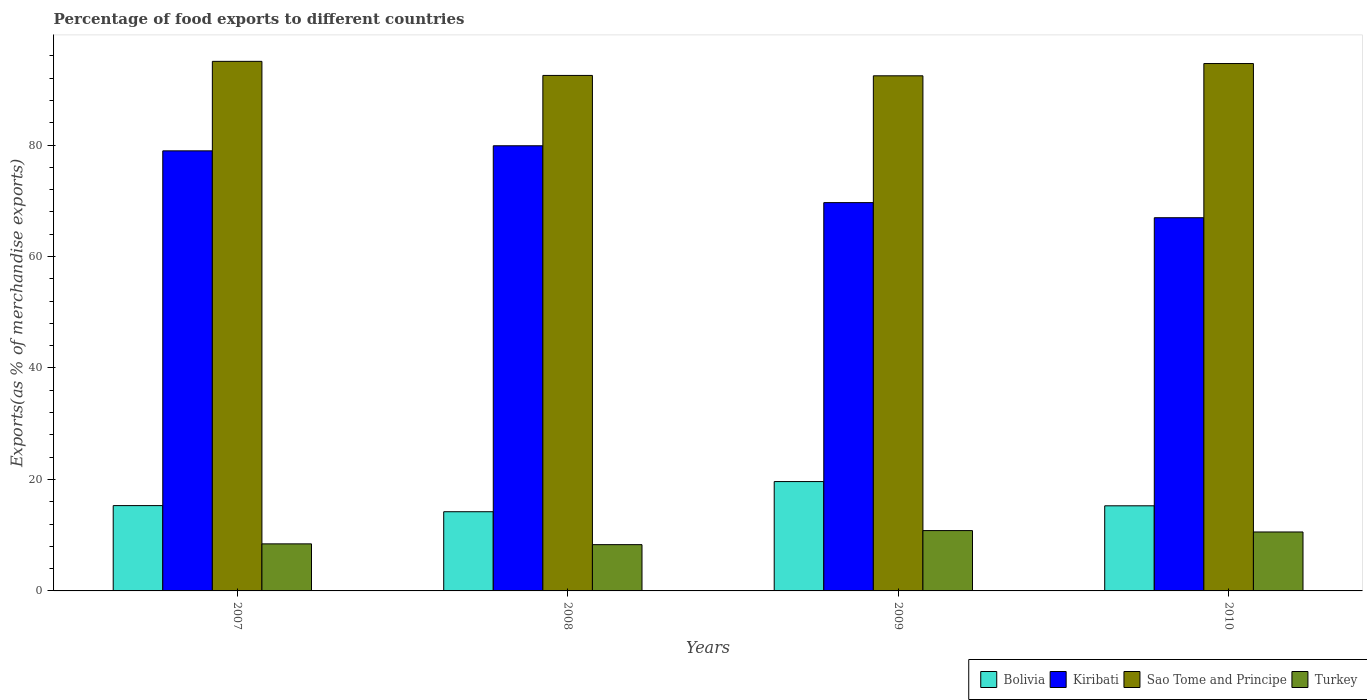How many different coloured bars are there?
Provide a succinct answer. 4. Are the number of bars per tick equal to the number of legend labels?
Your answer should be compact. Yes. How many bars are there on the 4th tick from the left?
Your response must be concise. 4. What is the percentage of exports to different countries in Bolivia in 2009?
Provide a short and direct response. 19.62. Across all years, what is the maximum percentage of exports to different countries in Turkey?
Your answer should be compact. 10.83. Across all years, what is the minimum percentage of exports to different countries in Sao Tome and Principe?
Provide a short and direct response. 92.42. What is the total percentage of exports to different countries in Turkey in the graph?
Provide a succinct answer. 38.15. What is the difference between the percentage of exports to different countries in Bolivia in 2009 and that in 2010?
Provide a short and direct response. 4.35. What is the difference between the percentage of exports to different countries in Sao Tome and Principe in 2010 and the percentage of exports to different countries in Kiribati in 2009?
Your answer should be compact. 24.95. What is the average percentage of exports to different countries in Turkey per year?
Ensure brevity in your answer.  9.54. In the year 2007, what is the difference between the percentage of exports to different countries in Kiribati and percentage of exports to different countries in Bolivia?
Your response must be concise. 63.64. In how many years, is the percentage of exports to different countries in Bolivia greater than 72 %?
Your answer should be very brief. 0. What is the ratio of the percentage of exports to different countries in Sao Tome and Principe in 2007 to that in 2009?
Give a very brief answer. 1.03. Is the percentage of exports to different countries in Sao Tome and Principe in 2007 less than that in 2010?
Ensure brevity in your answer.  No. What is the difference between the highest and the second highest percentage of exports to different countries in Bolivia?
Provide a short and direct response. 4.31. What is the difference between the highest and the lowest percentage of exports to different countries in Sao Tome and Principe?
Give a very brief answer. 2.59. What does the 2nd bar from the left in 2009 represents?
Offer a very short reply. Kiribati. What does the 4th bar from the right in 2010 represents?
Keep it short and to the point. Bolivia. What is the difference between two consecutive major ticks on the Y-axis?
Ensure brevity in your answer.  20. Are the values on the major ticks of Y-axis written in scientific E-notation?
Your response must be concise. No. Does the graph contain grids?
Give a very brief answer. No. Where does the legend appear in the graph?
Your answer should be compact. Bottom right. How many legend labels are there?
Offer a very short reply. 4. How are the legend labels stacked?
Your answer should be compact. Horizontal. What is the title of the graph?
Keep it short and to the point. Percentage of food exports to different countries. What is the label or title of the X-axis?
Provide a short and direct response. Years. What is the label or title of the Y-axis?
Provide a short and direct response. Exports(as % of merchandise exports). What is the Exports(as % of merchandise exports) in Bolivia in 2007?
Make the answer very short. 15.31. What is the Exports(as % of merchandise exports) of Kiribati in 2007?
Keep it short and to the point. 78.95. What is the Exports(as % of merchandise exports) in Sao Tome and Principe in 2007?
Make the answer very short. 95.01. What is the Exports(as % of merchandise exports) in Turkey in 2007?
Give a very brief answer. 8.44. What is the Exports(as % of merchandise exports) of Bolivia in 2008?
Your answer should be compact. 14.21. What is the Exports(as % of merchandise exports) in Kiribati in 2008?
Ensure brevity in your answer.  79.86. What is the Exports(as % of merchandise exports) of Sao Tome and Principe in 2008?
Keep it short and to the point. 92.48. What is the Exports(as % of merchandise exports) in Turkey in 2008?
Offer a terse response. 8.3. What is the Exports(as % of merchandise exports) in Bolivia in 2009?
Give a very brief answer. 19.62. What is the Exports(as % of merchandise exports) of Kiribati in 2009?
Make the answer very short. 69.66. What is the Exports(as % of merchandise exports) in Sao Tome and Principe in 2009?
Ensure brevity in your answer.  92.42. What is the Exports(as % of merchandise exports) in Turkey in 2009?
Offer a terse response. 10.83. What is the Exports(as % of merchandise exports) in Bolivia in 2010?
Keep it short and to the point. 15.27. What is the Exports(as % of merchandise exports) in Kiribati in 2010?
Your response must be concise. 66.95. What is the Exports(as % of merchandise exports) in Sao Tome and Principe in 2010?
Offer a terse response. 94.62. What is the Exports(as % of merchandise exports) in Turkey in 2010?
Give a very brief answer. 10.58. Across all years, what is the maximum Exports(as % of merchandise exports) of Bolivia?
Offer a terse response. 19.62. Across all years, what is the maximum Exports(as % of merchandise exports) of Kiribati?
Your response must be concise. 79.86. Across all years, what is the maximum Exports(as % of merchandise exports) in Sao Tome and Principe?
Provide a short and direct response. 95.01. Across all years, what is the maximum Exports(as % of merchandise exports) in Turkey?
Provide a short and direct response. 10.83. Across all years, what is the minimum Exports(as % of merchandise exports) of Bolivia?
Offer a very short reply. 14.21. Across all years, what is the minimum Exports(as % of merchandise exports) of Kiribati?
Provide a succinct answer. 66.95. Across all years, what is the minimum Exports(as % of merchandise exports) of Sao Tome and Principe?
Ensure brevity in your answer.  92.42. Across all years, what is the minimum Exports(as % of merchandise exports) of Turkey?
Offer a very short reply. 8.3. What is the total Exports(as % of merchandise exports) in Bolivia in the graph?
Offer a terse response. 64.41. What is the total Exports(as % of merchandise exports) in Kiribati in the graph?
Your answer should be very brief. 295.43. What is the total Exports(as % of merchandise exports) in Sao Tome and Principe in the graph?
Ensure brevity in your answer.  374.53. What is the total Exports(as % of merchandise exports) in Turkey in the graph?
Provide a short and direct response. 38.15. What is the difference between the Exports(as % of merchandise exports) of Bolivia in 2007 and that in 2008?
Your response must be concise. 1.1. What is the difference between the Exports(as % of merchandise exports) of Kiribati in 2007 and that in 2008?
Make the answer very short. -0.91. What is the difference between the Exports(as % of merchandise exports) in Sao Tome and Principe in 2007 and that in 2008?
Your answer should be compact. 2.52. What is the difference between the Exports(as % of merchandise exports) in Turkey in 2007 and that in 2008?
Offer a terse response. 0.14. What is the difference between the Exports(as % of merchandise exports) of Bolivia in 2007 and that in 2009?
Keep it short and to the point. -4.31. What is the difference between the Exports(as % of merchandise exports) of Kiribati in 2007 and that in 2009?
Your answer should be compact. 9.29. What is the difference between the Exports(as % of merchandise exports) of Sao Tome and Principe in 2007 and that in 2009?
Ensure brevity in your answer.  2.59. What is the difference between the Exports(as % of merchandise exports) of Turkey in 2007 and that in 2009?
Make the answer very short. -2.38. What is the difference between the Exports(as % of merchandise exports) of Bolivia in 2007 and that in 2010?
Ensure brevity in your answer.  0.04. What is the difference between the Exports(as % of merchandise exports) of Kiribati in 2007 and that in 2010?
Provide a succinct answer. 12. What is the difference between the Exports(as % of merchandise exports) of Sao Tome and Principe in 2007 and that in 2010?
Offer a very short reply. 0.39. What is the difference between the Exports(as % of merchandise exports) in Turkey in 2007 and that in 2010?
Provide a succinct answer. -2.13. What is the difference between the Exports(as % of merchandise exports) in Bolivia in 2008 and that in 2009?
Your answer should be very brief. -5.41. What is the difference between the Exports(as % of merchandise exports) in Kiribati in 2008 and that in 2009?
Your answer should be compact. 10.2. What is the difference between the Exports(as % of merchandise exports) in Sao Tome and Principe in 2008 and that in 2009?
Your answer should be compact. 0.07. What is the difference between the Exports(as % of merchandise exports) of Turkey in 2008 and that in 2009?
Provide a short and direct response. -2.52. What is the difference between the Exports(as % of merchandise exports) of Bolivia in 2008 and that in 2010?
Give a very brief answer. -1.06. What is the difference between the Exports(as % of merchandise exports) of Kiribati in 2008 and that in 2010?
Your response must be concise. 12.91. What is the difference between the Exports(as % of merchandise exports) of Sao Tome and Principe in 2008 and that in 2010?
Your response must be concise. -2.13. What is the difference between the Exports(as % of merchandise exports) of Turkey in 2008 and that in 2010?
Your answer should be very brief. -2.27. What is the difference between the Exports(as % of merchandise exports) in Bolivia in 2009 and that in 2010?
Provide a succinct answer. 4.35. What is the difference between the Exports(as % of merchandise exports) of Kiribati in 2009 and that in 2010?
Your response must be concise. 2.71. What is the difference between the Exports(as % of merchandise exports) of Turkey in 2009 and that in 2010?
Keep it short and to the point. 0.25. What is the difference between the Exports(as % of merchandise exports) of Bolivia in 2007 and the Exports(as % of merchandise exports) of Kiribati in 2008?
Your response must be concise. -64.56. What is the difference between the Exports(as % of merchandise exports) of Bolivia in 2007 and the Exports(as % of merchandise exports) of Sao Tome and Principe in 2008?
Your answer should be compact. -77.18. What is the difference between the Exports(as % of merchandise exports) of Bolivia in 2007 and the Exports(as % of merchandise exports) of Turkey in 2008?
Ensure brevity in your answer.  7.01. What is the difference between the Exports(as % of merchandise exports) in Kiribati in 2007 and the Exports(as % of merchandise exports) in Sao Tome and Principe in 2008?
Ensure brevity in your answer.  -13.53. What is the difference between the Exports(as % of merchandise exports) of Kiribati in 2007 and the Exports(as % of merchandise exports) of Turkey in 2008?
Your answer should be very brief. 70.65. What is the difference between the Exports(as % of merchandise exports) of Sao Tome and Principe in 2007 and the Exports(as % of merchandise exports) of Turkey in 2008?
Make the answer very short. 86.71. What is the difference between the Exports(as % of merchandise exports) of Bolivia in 2007 and the Exports(as % of merchandise exports) of Kiribati in 2009?
Give a very brief answer. -54.36. What is the difference between the Exports(as % of merchandise exports) of Bolivia in 2007 and the Exports(as % of merchandise exports) of Sao Tome and Principe in 2009?
Provide a succinct answer. -77.11. What is the difference between the Exports(as % of merchandise exports) of Bolivia in 2007 and the Exports(as % of merchandise exports) of Turkey in 2009?
Offer a very short reply. 4.48. What is the difference between the Exports(as % of merchandise exports) in Kiribati in 2007 and the Exports(as % of merchandise exports) in Sao Tome and Principe in 2009?
Make the answer very short. -13.46. What is the difference between the Exports(as % of merchandise exports) of Kiribati in 2007 and the Exports(as % of merchandise exports) of Turkey in 2009?
Your response must be concise. 68.13. What is the difference between the Exports(as % of merchandise exports) of Sao Tome and Principe in 2007 and the Exports(as % of merchandise exports) of Turkey in 2009?
Offer a terse response. 84.18. What is the difference between the Exports(as % of merchandise exports) in Bolivia in 2007 and the Exports(as % of merchandise exports) in Kiribati in 2010?
Make the answer very short. -51.65. What is the difference between the Exports(as % of merchandise exports) in Bolivia in 2007 and the Exports(as % of merchandise exports) in Sao Tome and Principe in 2010?
Offer a very short reply. -79.31. What is the difference between the Exports(as % of merchandise exports) of Bolivia in 2007 and the Exports(as % of merchandise exports) of Turkey in 2010?
Make the answer very short. 4.73. What is the difference between the Exports(as % of merchandise exports) of Kiribati in 2007 and the Exports(as % of merchandise exports) of Sao Tome and Principe in 2010?
Offer a terse response. -15.66. What is the difference between the Exports(as % of merchandise exports) of Kiribati in 2007 and the Exports(as % of merchandise exports) of Turkey in 2010?
Give a very brief answer. 68.38. What is the difference between the Exports(as % of merchandise exports) of Sao Tome and Principe in 2007 and the Exports(as % of merchandise exports) of Turkey in 2010?
Ensure brevity in your answer.  84.43. What is the difference between the Exports(as % of merchandise exports) of Bolivia in 2008 and the Exports(as % of merchandise exports) of Kiribati in 2009?
Your answer should be very brief. -55.46. What is the difference between the Exports(as % of merchandise exports) in Bolivia in 2008 and the Exports(as % of merchandise exports) in Sao Tome and Principe in 2009?
Provide a short and direct response. -78.21. What is the difference between the Exports(as % of merchandise exports) of Bolivia in 2008 and the Exports(as % of merchandise exports) of Turkey in 2009?
Ensure brevity in your answer.  3.38. What is the difference between the Exports(as % of merchandise exports) of Kiribati in 2008 and the Exports(as % of merchandise exports) of Sao Tome and Principe in 2009?
Your response must be concise. -12.55. What is the difference between the Exports(as % of merchandise exports) in Kiribati in 2008 and the Exports(as % of merchandise exports) in Turkey in 2009?
Offer a very short reply. 69.04. What is the difference between the Exports(as % of merchandise exports) in Sao Tome and Principe in 2008 and the Exports(as % of merchandise exports) in Turkey in 2009?
Your answer should be compact. 81.66. What is the difference between the Exports(as % of merchandise exports) in Bolivia in 2008 and the Exports(as % of merchandise exports) in Kiribati in 2010?
Keep it short and to the point. -52.75. What is the difference between the Exports(as % of merchandise exports) of Bolivia in 2008 and the Exports(as % of merchandise exports) of Sao Tome and Principe in 2010?
Keep it short and to the point. -80.41. What is the difference between the Exports(as % of merchandise exports) in Bolivia in 2008 and the Exports(as % of merchandise exports) in Turkey in 2010?
Give a very brief answer. 3.63. What is the difference between the Exports(as % of merchandise exports) in Kiribati in 2008 and the Exports(as % of merchandise exports) in Sao Tome and Principe in 2010?
Your answer should be very brief. -14.75. What is the difference between the Exports(as % of merchandise exports) in Kiribati in 2008 and the Exports(as % of merchandise exports) in Turkey in 2010?
Keep it short and to the point. 69.29. What is the difference between the Exports(as % of merchandise exports) in Sao Tome and Principe in 2008 and the Exports(as % of merchandise exports) in Turkey in 2010?
Provide a succinct answer. 81.91. What is the difference between the Exports(as % of merchandise exports) in Bolivia in 2009 and the Exports(as % of merchandise exports) in Kiribati in 2010?
Give a very brief answer. -47.33. What is the difference between the Exports(as % of merchandise exports) in Bolivia in 2009 and the Exports(as % of merchandise exports) in Sao Tome and Principe in 2010?
Provide a succinct answer. -75. What is the difference between the Exports(as % of merchandise exports) of Bolivia in 2009 and the Exports(as % of merchandise exports) of Turkey in 2010?
Ensure brevity in your answer.  9.04. What is the difference between the Exports(as % of merchandise exports) of Kiribati in 2009 and the Exports(as % of merchandise exports) of Sao Tome and Principe in 2010?
Your response must be concise. -24.95. What is the difference between the Exports(as % of merchandise exports) in Kiribati in 2009 and the Exports(as % of merchandise exports) in Turkey in 2010?
Your answer should be compact. 59.09. What is the difference between the Exports(as % of merchandise exports) of Sao Tome and Principe in 2009 and the Exports(as % of merchandise exports) of Turkey in 2010?
Keep it short and to the point. 81.84. What is the average Exports(as % of merchandise exports) in Bolivia per year?
Provide a succinct answer. 16.1. What is the average Exports(as % of merchandise exports) of Kiribati per year?
Keep it short and to the point. 73.86. What is the average Exports(as % of merchandise exports) in Sao Tome and Principe per year?
Offer a terse response. 93.63. What is the average Exports(as % of merchandise exports) in Turkey per year?
Offer a terse response. 9.54. In the year 2007, what is the difference between the Exports(as % of merchandise exports) of Bolivia and Exports(as % of merchandise exports) of Kiribati?
Your answer should be compact. -63.64. In the year 2007, what is the difference between the Exports(as % of merchandise exports) of Bolivia and Exports(as % of merchandise exports) of Sao Tome and Principe?
Offer a terse response. -79.7. In the year 2007, what is the difference between the Exports(as % of merchandise exports) in Bolivia and Exports(as % of merchandise exports) in Turkey?
Give a very brief answer. 6.87. In the year 2007, what is the difference between the Exports(as % of merchandise exports) in Kiribati and Exports(as % of merchandise exports) in Sao Tome and Principe?
Ensure brevity in your answer.  -16.06. In the year 2007, what is the difference between the Exports(as % of merchandise exports) of Kiribati and Exports(as % of merchandise exports) of Turkey?
Your response must be concise. 70.51. In the year 2007, what is the difference between the Exports(as % of merchandise exports) in Sao Tome and Principe and Exports(as % of merchandise exports) in Turkey?
Provide a succinct answer. 86.57. In the year 2008, what is the difference between the Exports(as % of merchandise exports) in Bolivia and Exports(as % of merchandise exports) in Kiribati?
Offer a very short reply. -65.66. In the year 2008, what is the difference between the Exports(as % of merchandise exports) in Bolivia and Exports(as % of merchandise exports) in Sao Tome and Principe?
Offer a terse response. -78.28. In the year 2008, what is the difference between the Exports(as % of merchandise exports) in Bolivia and Exports(as % of merchandise exports) in Turkey?
Your answer should be compact. 5.9. In the year 2008, what is the difference between the Exports(as % of merchandise exports) of Kiribati and Exports(as % of merchandise exports) of Sao Tome and Principe?
Offer a terse response. -12.62. In the year 2008, what is the difference between the Exports(as % of merchandise exports) in Kiribati and Exports(as % of merchandise exports) in Turkey?
Provide a succinct answer. 71.56. In the year 2008, what is the difference between the Exports(as % of merchandise exports) of Sao Tome and Principe and Exports(as % of merchandise exports) of Turkey?
Give a very brief answer. 84.18. In the year 2009, what is the difference between the Exports(as % of merchandise exports) of Bolivia and Exports(as % of merchandise exports) of Kiribati?
Offer a very short reply. -50.04. In the year 2009, what is the difference between the Exports(as % of merchandise exports) of Bolivia and Exports(as % of merchandise exports) of Sao Tome and Principe?
Make the answer very short. -72.8. In the year 2009, what is the difference between the Exports(as % of merchandise exports) in Bolivia and Exports(as % of merchandise exports) in Turkey?
Give a very brief answer. 8.79. In the year 2009, what is the difference between the Exports(as % of merchandise exports) of Kiribati and Exports(as % of merchandise exports) of Sao Tome and Principe?
Provide a succinct answer. -22.75. In the year 2009, what is the difference between the Exports(as % of merchandise exports) of Kiribati and Exports(as % of merchandise exports) of Turkey?
Offer a terse response. 58.84. In the year 2009, what is the difference between the Exports(as % of merchandise exports) in Sao Tome and Principe and Exports(as % of merchandise exports) in Turkey?
Provide a succinct answer. 81.59. In the year 2010, what is the difference between the Exports(as % of merchandise exports) of Bolivia and Exports(as % of merchandise exports) of Kiribati?
Your answer should be very brief. -51.68. In the year 2010, what is the difference between the Exports(as % of merchandise exports) in Bolivia and Exports(as % of merchandise exports) in Sao Tome and Principe?
Provide a succinct answer. -79.35. In the year 2010, what is the difference between the Exports(as % of merchandise exports) of Bolivia and Exports(as % of merchandise exports) of Turkey?
Offer a terse response. 4.69. In the year 2010, what is the difference between the Exports(as % of merchandise exports) in Kiribati and Exports(as % of merchandise exports) in Sao Tome and Principe?
Offer a terse response. -27.66. In the year 2010, what is the difference between the Exports(as % of merchandise exports) in Kiribati and Exports(as % of merchandise exports) in Turkey?
Provide a short and direct response. 56.38. In the year 2010, what is the difference between the Exports(as % of merchandise exports) of Sao Tome and Principe and Exports(as % of merchandise exports) of Turkey?
Provide a succinct answer. 84.04. What is the ratio of the Exports(as % of merchandise exports) in Bolivia in 2007 to that in 2008?
Keep it short and to the point. 1.08. What is the ratio of the Exports(as % of merchandise exports) in Sao Tome and Principe in 2007 to that in 2008?
Offer a terse response. 1.03. What is the ratio of the Exports(as % of merchandise exports) in Turkey in 2007 to that in 2008?
Your answer should be compact. 1.02. What is the ratio of the Exports(as % of merchandise exports) of Bolivia in 2007 to that in 2009?
Provide a short and direct response. 0.78. What is the ratio of the Exports(as % of merchandise exports) of Kiribati in 2007 to that in 2009?
Your answer should be compact. 1.13. What is the ratio of the Exports(as % of merchandise exports) in Sao Tome and Principe in 2007 to that in 2009?
Ensure brevity in your answer.  1.03. What is the ratio of the Exports(as % of merchandise exports) in Turkey in 2007 to that in 2009?
Your answer should be very brief. 0.78. What is the ratio of the Exports(as % of merchandise exports) of Kiribati in 2007 to that in 2010?
Keep it short and to the point. 1.18. What is the ratio of the Exports(as % of merchandise exports) in Turkey in 2007 to that in 2010?
Give a very brief answer. 0.8. What is the ratio of the Exports(as % of merchandise exports) in Bolivia in 2008 to that in 2009?
Give a very brief answer. 0.72. What is the ratio of the Exports(as % of merchandise exports) of Kiribati in 2008 to that in 2009?
Offer a terse response. 1.15. What is the ratio of the Exports(as % of merchandise exports) in Turkey in 2008 to that in 2009?
Provide a succinct answer. 0.77. What is the ratio of the Exports(as % of merchandise exports) of Bolivia in 2008 to that in 2010?
Provide a succinct answer. 0.93. What is the ratio of the Exports(as % of merchandise exports) in Kiribati in 2008 to that in 2010?
Offer a very short reply. 1.19. What is the ratio of the Exports(as % of merchandise exports) in Sao Tome and Principe in 2008 to that in 2010?
Your response must be concise. 0.98. What is the ratio of the Exports(as % of merchandise exports) of Turkey in 2008 to that in 2010?
Keep it short and to the point. 0.79. What is the ratio of the Exports(as % of merchandise exports) in Bolivia in 2009 to that in 2010?
Ensure brevity in your answer.  1.28. What is the ratio of the Exports(as % of merchandise exports) in Kiribati in 2009 to that in 2010?
Make the answer very short. 1.04. What is the ratio of the Exports(as % of merchandise exports) of Sao Tome and Principe in 2009 to that in 2010?
Make the answer very short. 0.98. What is the ratio of the Exports(as % of merchandise exports) in Turkey in 2009 to that in 2010?
Your answer should be compact. 1.02. What is the difference between the highest and the second highest Exports(as % of merchandise exports) in Bolivia?
Make the answer very short. 4.31. What is the difference between the highest and the second highest Exports(as % of merchandise exports) of Kiribati?
Ensure brevity in your answer.  0.91. What is the difference between the highest and the second highest Exports(as % of merchandise exports) in Sao Tome and Principe?
Make the answer very short. 0.39. What is the difference between the highest and the second highest Exports(as % of merchandise exports) in Turkey?
Keep it short and to the point. 0.25. What is the difference between the highest and the lowest Exports(as % of merchandise exports) in Bolivia?
Make the answer very short. 5.41. What is the difference between the highest and the lowest Exports(as % of merchandise exports) in Kiribati?
Ensure brevity in your answer.  12.91. What is the difference between the highest and the lowest Exports(as % of merchandise exports) of Sao Tome and Principe?
Give a very brief answer. 2.59. What is the difference between the highest and the lowest Exports(as % of merchandise exports) of Turkey?
Offer a terse response. 2.52. 